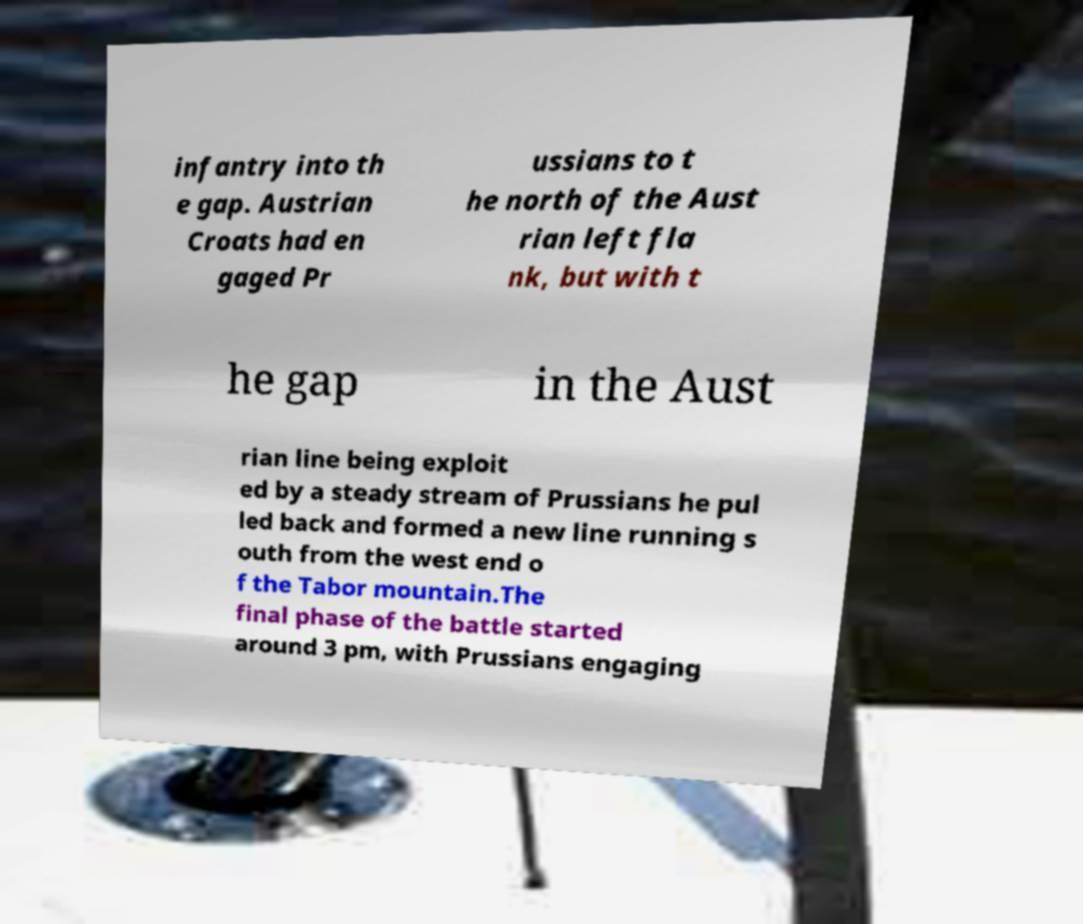Could you extract and type out the text from this image? infantry into th e gap. Austrian Croats had en gaged Pr ussians to t he north of the Aust rian left fla nk, but with t he gap in the Aust rian line being exploit ed by a steady stream of Prussians he pul led back and formed a new line running s outh from the west end o f the Tabor mountain.The final phase of the battle started around 3 pm, with Prussians engaging 